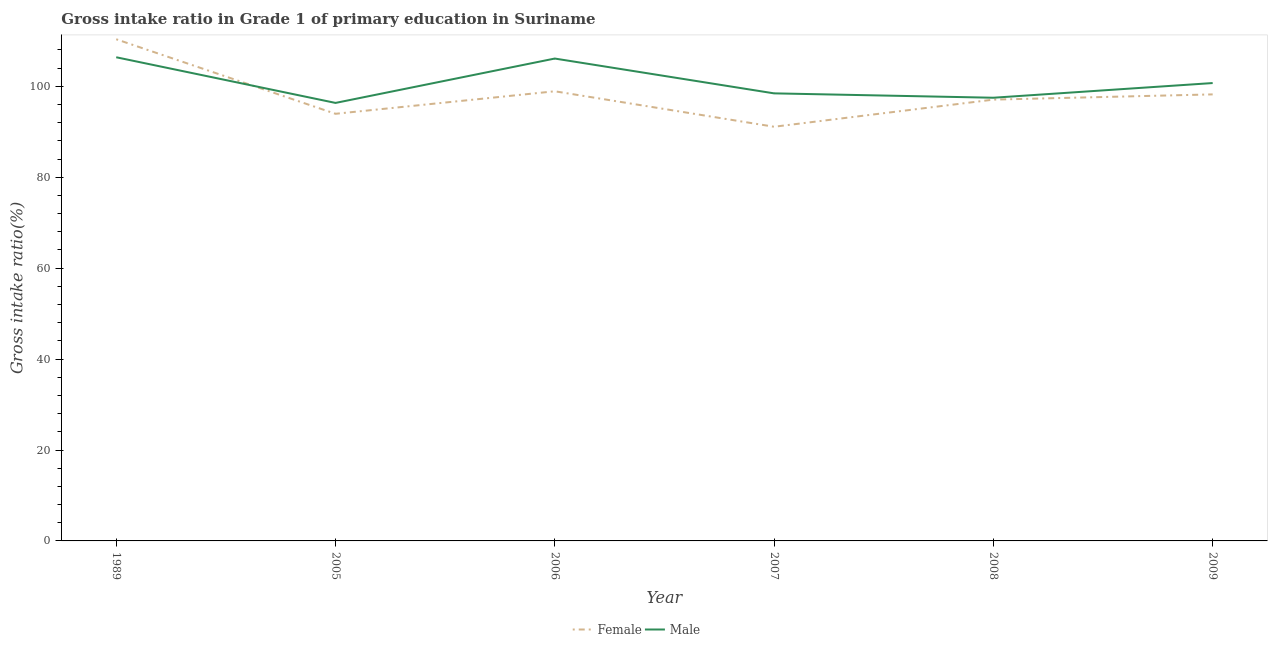How many different coloured lines are there?
Offer a terse response. 2. Does the line corresponding to gross intake ratio(female) intersect with the line corresponding to gross intake ratio(male)?
Offer a terse response. Yes. Is the number of lines equal to the number of legend labels?
Ensure brevity in your answer.  Yes. What is the gross intake ratio(male) in 2007?
Provide a succinct answer. 98.45. Across all years, what is the maximum gross intake ratio(male)?
Your answer should be very brief. 106.4. Across all years, what is the minimum gross intake ratio(female)?
Your response must be concise. 91.11. What is the total gross intake ratio(female) in the graph?
Offer a terse response. 589.65. What is the difference between the gross intake ratio(male) in 2006 and that in 2007?
Your answer should be very brief. 7.66. What is the difference between the gross intake ratio(female) in 2009 and the gross intake ratio(male) in 2006?
Your response must be concise. -7.88. What is the average gross intake ratio(male) per year?
Ensure brevity in your answer.  100.92. In the year 2008, what is the difference between the gross intake ratio(male) and gross intake ratio(female)?
Your answer should be very brief. 0.42. What is the ratio of the gross intake ratio(male) in 1989 to that in 2009?
Your response must be concise. 1.06. Is the gross intake ratio(male) in 1989 less than that in 2009?
Provide a succinct answer. No. What is the difference between the highest and the second highest gross intake ratio(male)?
Provide a succinct answer. 0.28. What is the difference between the highest and the lowest gross intake ratio(male)?
Ensure brevity in your answer.  10.05. Is the gross intake ratio(male) strictly greater than the gross intake ratio(female) over the years?
Your response must be concise. No. How many lines are there?
Provide a short and direct response. 2. How many years are there in the graph?
Give a very brief answer. 6. Does the graph contain grids?
Provide a short and direct response. No. What is the title of the graph?
Ensure brevity in your answer.  Gross intake ratio in Grade 1 of primary education in Suriname. Does "Rural" appear as one of the legend labels in the graph?
Provide a succinct answer. No. What is the label or title of the X-axis?
Ensure brevity in your answer.  Year. What is the label or title of the Y-axis?
Give a very brief answer. Gross intake ratio(%). What is the Gross intake ratio(%) in Female in 1989?
Offer a terse response. 110.36. What is the Gross intake ratio(%) in Male in 1989?
Your response must be concise. 106.4. What is the Gross intake ratio(%) in Female in 2005?
Ensure brevity in your answer.  93.96. What is the Gross intake ratio(%) in Male in 2005?
Your answer should be very brief. 96.35. What is the Gross intake ratio(%) of Female in 2006?
Keep it short and to the point. 98.91. What is the Gross intake ratio(%) in Male in 2006?
Make the answer very short. 106.12. What is the Gross intake ratio(%) of Female in 2007?
Your answer should be compact. 91.11. What is the Gross intake ratio(%) of Male in 2007?
Ensure brevity in your answer.  98.45. What is the Gross intake ratio(%) of Female in 2008?
Give a very brief answer. 97.08. What is the Gross intake ratio(%) in Male in 2008?
Your answer should be compact. 97.5. What is the Gross intake ratio(%) of Female in 2009?
Provide a short and direct response. 98.23. What is the Gross intake ratio(%) in Male in 2009?
Your answer should be compact. 100.73. Across all years, what is the maximum Gross intake ratio(%) of Female?
Keep it short and to the point. 110.36. Across all years, what is the maximum Gross intake ratio(%) of Male?
Give a very brief answer. 106.4. Across all years, what is the minimum Gross intake ratio(%) of Female?
Give a very brief answer. 91.11. Across all years, what is the minimum Gross intake ratio(%) in Male?
Offer a terse response. 96.35. What is the total Gross intake ratio(%) of Female in the graph?
Provide a short and direct response. 589.65. What is the total Gross intake ratio(%) of Male in the graph?
Offer a terse response. 605.54. What is the difference between the Gross intake ratio(%) in Female in 1989 and that in 2005?
Your answer should be compact. 16.4. What is the difference between the Gross intake ratio(%) of Male in 1989 and that in 2005?
Your answer should be very brief. 10.05. What is the difference between the Gross intake ratio(%) in Female in 1989 and that in 2006?
Provide a short and direct response. 11.45. What is the difference between the Gross intake ratio(%) in Male in 1989 and that in 2006?
Give a very brief answer. 0.28. What is the difference between the Gross intake ratio(%) in Female in 1989 and that in 2007?
Provide a succinct answer. 19.25. What is the difference between the Gross intake ratio(%) of Male in 1989 and that in 2007?
Your answer should be very brief. 7.94. What is the difference between the Gross intake ratio(%) of Female in 1989 and that in 2008?
Your answer should be very brief. 13.28. What is the difference between the Gross intake ratio(%) in Male in 1989 and that in 2008?
Provide a succinct answer. 8.9. What is the difference between the Gross intake ratio(%) of Female in 1989 and that in 2009?
Make the answer very short. 12.13. What is the difference between the Gross intake ratio(%) in Male in 1989 and that in 2009?
Provide a short and direct response. 5.67. What is the difference between the Gross intake ratio(%) in Female in 2005 and that in 2006?
Provide a succinct answer. -4.95. What is the difference between the Gross intake ratio(%) in Male in 2005 and that in 2006?
Your response must be concise. -9.76. What is the difference between the Gross intake ratio(%) in Female in 2005 and that in 2007?
Offer a terse response. 2.85. What is the difference between the Gross intake ratio(%) in Male in 2005 and that in 2007?
Your answer should be compact. -2.1. What is the difference between the Gross intake ratio(%) in Female in 2005 and that in 2008?
Make the answer very short. -3.12. What is the difference between the Gross intake ratio(%) in Male in 2005 and that in 2008?
Keep it short and to the point. -1.14. What is the difference between the Gross intake ratio(%) of Female in 2005 and that in 2009?
Keep it short and to the point. -4.27. What is the difference between the Gross intake ratio(%) of Male in 2005 and that in 2009?
Provide a succinct answer. -4.37. What is the difference between the Gross intake ratio(%) of Female in 2006 and that in 2007?
Your response must be concise. 7.8. What is the difference between the Gross intake ratio(%) in Male in 2006 and that in 2007?
Your answer should be very brief. 7.66. What is the difference between the Gross intake ratio(%) of Female in 2006 and that in 2008?
Make the answer very short. 1.83. What is the difference between the Gross intake ratio(%) in Male in 2006 and that in 2008?
Offer a very short reply. 8.62. What is the difference between the Gross intake ratio(%) of Female in 2006 and that in 2009?
Make the answer very short. 0.68. What is the difference between the Gross intake ratio(%) in Male in 2006 and that in 2009?
Give a very brief answer. 5.39. What is the difference between the Gross intake ratio(%) of Female in 2007 and that in 2008?
Your answer should be compact. -5.97. What is the difference between the Gross intake ratio(%) in Male in 2007 and that in 2008?
Provide a succinct answer. 0.96. What is the difference between the Gross intake ratio(%) in Female in 2007 and that in 2009?
Keep it short and to the point. -7.12. What is the difference between the Gross intake ratio(%) in Male in 2007 and that in 2009?
Your answer should be very brief. -2.27. What is the difference between the Gross intake ratio(%) of Female in 2008 and that in 2009?
Ensure brevity in your answer.  -1.15. What is the difference between the Gross intake ratio(%) of Male in 2008 and that in 2009?
Your response must be concise. -3.23. What is the difference between the Gross intake ratio(%) in Female in 1989 and the Gross intake ratio(%) in Male in 2005?
Offer a terse response. 14.01. What is the difference between the Gross intake ratio(%) in Female in 1989 and the Gross intake ratio(%) in Male in 2006?
Ensure brevity in your answer.  4.24. What is the difference between the Gross intake ratio(%) of Female in 1989 and the Gross intake ratio(%) of Male in 2007?
Ensure brevity in your answer.  11.9. What is the difference between the Gross intake ratio(%) of Female in 1989 and the Gross intake ratio(%) of Male in 2008?
Offer a very short reply. 12.86. What is the difference between the Gross intake ratio(%) of Female in 1989 and the Gross intake ratio(%) of Male in 2009?
Your answer should be very brief. 9.63. What is the difference between the Gross intake ratio(%) in Female in 2005 and the Gross intake ratio(%) in Male in 2006?
Keep it short and to the point. -12.15. What is the difference between the Gross intake ratio(%) of Female in 2005 and the Gross intake ratio(%) of Male in 2007?
Make the answer very short. -4.49. What is the difference between the Gross intake ratio(%) of Female in 2005 and the Gross intake ratio(%) of Male in 2008?
Make the answer very short. -3.53. What is the difference between the Gross intake ratio(%) of Female in 2005 and the Gross intake ratio(%) of Male in 2009?
Your answer should be very brief. -6.76. What is the difference between the Gross intake ratio(%) in Female in 2006 and the Gross intake ratio(%) in Male in 2007?
Keep it short and to the point. 0.46. What is the difference between the Gross intake ratio(%) of Female in 2006 and the Gross intake ratio(%) of Male in 2008?
Offer a terse response. 1.42. What is the difference between the Gross intake ratio(%) of Female in 2006 and the Gross intake ratio(%) of Male in 2009?
Give a very brief answer. -1.81. What is the difference between the Gross intake ratio(%) in Female in 2007 and the Gross intake ratio(%) in Male in 2008?
Offer a very short reply. -6.38. What is the difference between the Gross intake ratio(%) of Female in 2007 and the Gross intake ratio(%) of Male in 2009?
Make the answer very short. -9.61. What is the difference between the Gross intake ratio(%) in Female in 2008 and the Gross intake ratio(%) in Male in 2009?
Your answer should be compact. -3.65. What is the average Gross intake ratio(%) of Female per year?
Provide a succinct answer. 98.28. What is the average Gross intake ratio(%) of Male per year?
Offer a terse response. 100.92. In the year 1989, what is the difference between the Gross intake ratio(%) in Female and Gross intake ratio(%) in Male?
Your answer should be very brief. 3.96. In the year 2005, what is the difference between the Gross intake ratio(%) of Female and Gross intake ratio(%) of Male?
Provide a succinct answer. -2.39. In the year 2006, what is the difference between the Gross intake ratio(%) of Female and Gross intake ratio(%) of Male?
Make the answer very short. -7.2. In the year 2007, what is the difference between the Gross intake ratio(%) in Female and Gross intake ratio(%) in Male?
Provide a short and direct response. -7.34. In the year 2008, what is the difference between the Gross intake ratio(%) in Female and Gross intake ratio(%) in Male?
Give a very brief answer. -0.42. In the year 2009, what is the difference between the Gross intake ratio(%) of Female and Gross intake ratio(%) of Male?
Give a very brief answer. -2.49. What is the ratio of the Gross intake ratio(%) of Female in 1989 to that in 2005?
Your answer should be compact. 1.17. What is the ratio of the Gross intake ratio(%) of Male in 1989 to that in 2005?
Offer a terse response. 1.1. What is the ratio of the Gross intake ratio(%) in Female in 1989 to that in 2006?
Provide a short and direct response. 1.12. What is the ratio of the Gross intake ratio(%) of Female in 1989 to that in 2007?
Offer a very short reply. 1.21. What is the ratio of the Gross intake ratio(%) of Male in 1989 to that in 2007?
Offer a very short reply. 1.08. What is the ratio of the Gross intake ratio(%) in Female in 1989 to that in 2008?
Your answer should be very brief. 1.14. What is the ratio of the Gross intake ratio(%) of Male in 1989 to that in 2008?
Offer a very short reply. 1.09. What is the ratio of the Gross intake ratio(%) of Female in 1989 to that in 2009?
Make the answer very short. 1.12. What is the ratio of the Gross intake ratio(%) of Male in 1989 to that in 2009?
Offer a very short reply. 1.06. What is the ratio of the Gross intake ratio(%) of Female in 2005 to that in 2006?
Give a very brief answer. 0.95. What is the ratio of the Gross intake ratio(%) in Male in 2005 to that in 2006?
Offer a very short reply. 0.91. What is the ratio of the Gross intake ratio(%) in Female in 2005 to that in 2007?
Your answer should be compact. 1.03. What is the ratio of the Gross intake ratio(%) of Male in 2005 to that in 2007?
Offer a very short reply. 0.98. What is the ratio of the Gross intake ratio(%) of Female in 2005 to that in 2008?
Give a very brief answer. 0.97. What is the ratio of the Gross intake ratio(%) of Male in 2005 to that in 2008?
Your response must be concise. 0.99. What is the ratio of the Gross intake ratio(%) of Female in 2005 to that in 2009?
Your answer should be very brief. 0.96. What is the ratio of the Gross intake ratio(%) in Male in 2005 to that in 2009?
Provide a succinct answer. 0.96. What is the ratio of the Gross intake ratio(%) in Female in 2006 to that in 2007?
Offer a very short reply. 1.09. What is the ratio of the Gross intake ratio(%) in Male in 2006 to that in 2007?
Give a very brief answer. 1.08. What is the ratio of the Gross intake ratio(%) in Female in 2006 to that in 2008?
Offer a very short reply. 1.02. What is the ratio of the Gross intake ratio(%) of Male in 2006 to that in 2008?
Make the answer very short. 1.09. What is the ratio of the Gross intake ratio(%) in Female in 2006 to that in 2009?
Offer a very short reply. 1.01. What is the ratio of the Gross intake ratio(%) in Male in 2006 to that in 2009?
Your answer should be compact. 1.05. What is the ratio of the Gross intake ratio(%) in Female in 2007 to that in 2008?
Offer a very short reply. 0.94. What is the ratio of the Gross intake ratio(%) of Male in 2007 to that in 2008?
Your answer should be compact. 1.01. What is the ratio of the Gross intake ratio(%) in Female in 2007 to that in 2009?
Your answer should be compact. 0.93. What is the ratio of the Gross intake ratio(%) in Male in 2007 to that in 2009?
Give a very brief answer. 0.98. What is the ratio of the Gross intake ratio(%) of Female in 2008 to that in 2009?
Offer a terse response. 0.99. What is the ratio of the Gross intake ratio(%) of Male in 2008 to that in 2009?
Your response must be concise. 0.97. What is the difference between the highest and the second highest Gross intake ratio(%) in Female?
Make the answer very short. 11.45. What is the difference between the highest and the second highest Gross intake ratio(%) in Male?
Give a very brief answer. 0.28. What is the difference between the highest and the lowest Gross intake ratio(%) in Female?
Make the answer very short. 19.25. What is the difference between the highest and the lowest Gross intake ratio(%) of Male?
Offer a very short reply. 10.05. 